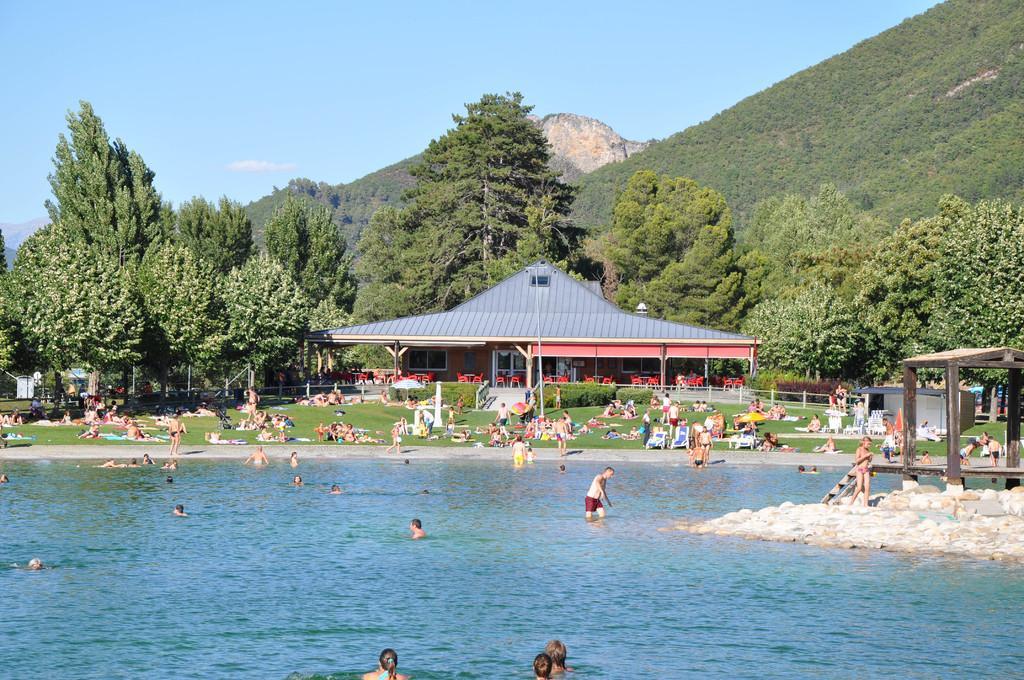How would you summarize this image in a sentence or two? This picture is clicked outside. In the foreground we can see the group of persons and some other objects in the water body and we can see the rocks and a gazebo. In the background we can see the sky, hills, trees and we can see a house and we can see the group of persons, green grass, plants, chairs, tables and many other objects. 